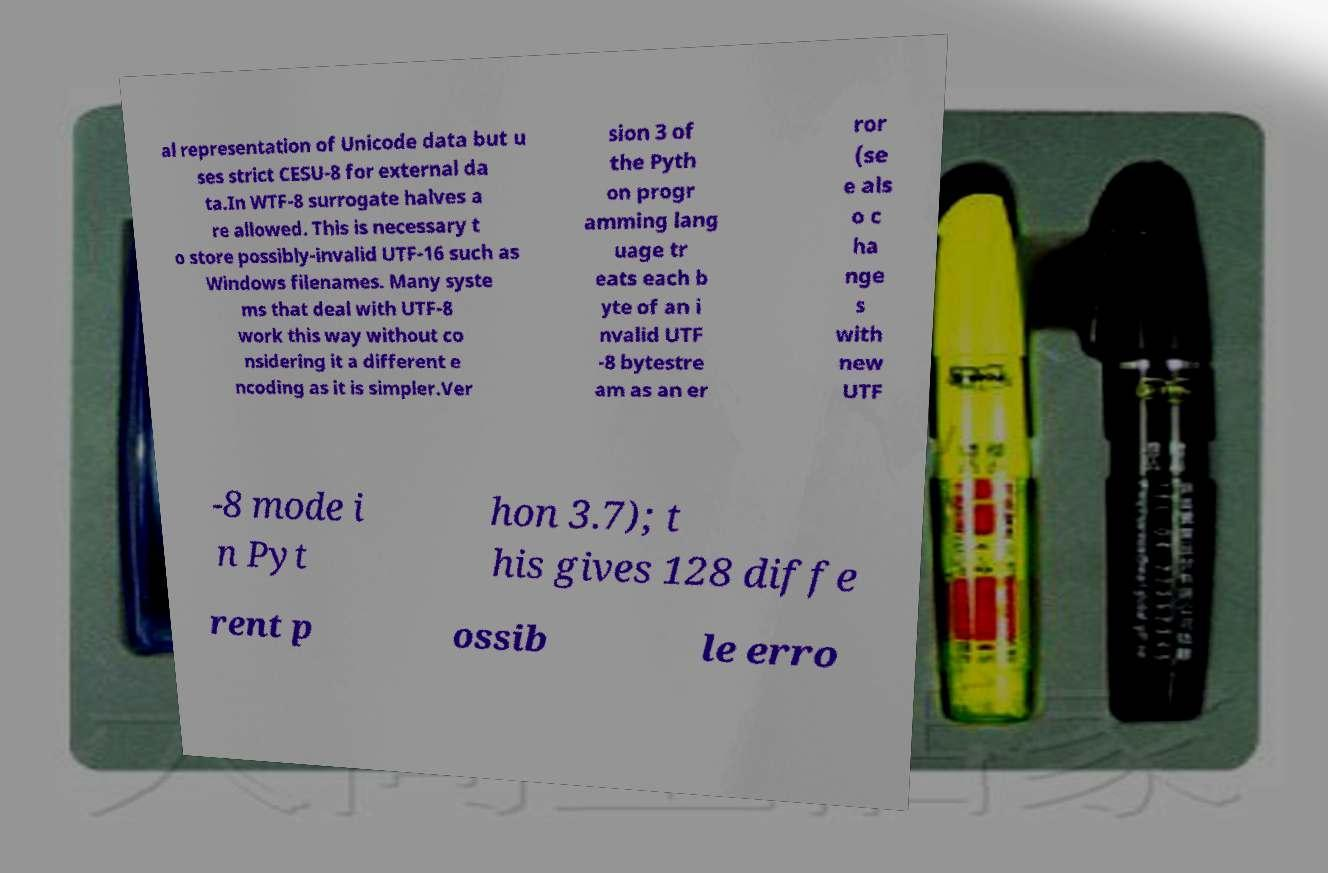Can you accurately transcribe the text from the provided image for me? al representation of Unicode data but u ses strict CESU-8 for external da ta.In WTF-8 surrogate halves a re allowed. This is necessary t o store possibly-invalid UTF-16 such as Windows filenames. Many syste ms that deal with UTF-8 work this way without co nsidering it a different e ncoding as it is simpler.Ver sion 3 of the Pyth on progr amming lang uage tr eats each b yte of an i nvalid UTF -8 bytestre am as an er ror (se e als o c ha nge s with new UTF -8 mode i n Pyt hon 3.7); t his gives 128 diffe rent p ossib le erro 